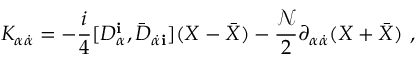<formula> <loc_0><loc_0><loc_500><loc_500>K _ { \alpha { \dot { \alpha } } } = - \frac { i } { 4 } [ D _ { \alpha } ^ { \mathbf i } , { \bar { D } } _ { { \dot { \alpha } } { \mathbf i } } ] ( X - { \bar { X } } ) - \frac { \mathcal { N } } { 2 } \partial _ { \alpha { \dot { \alpha } } } ( X + { \bar { X } } ) \ ,</formula> 